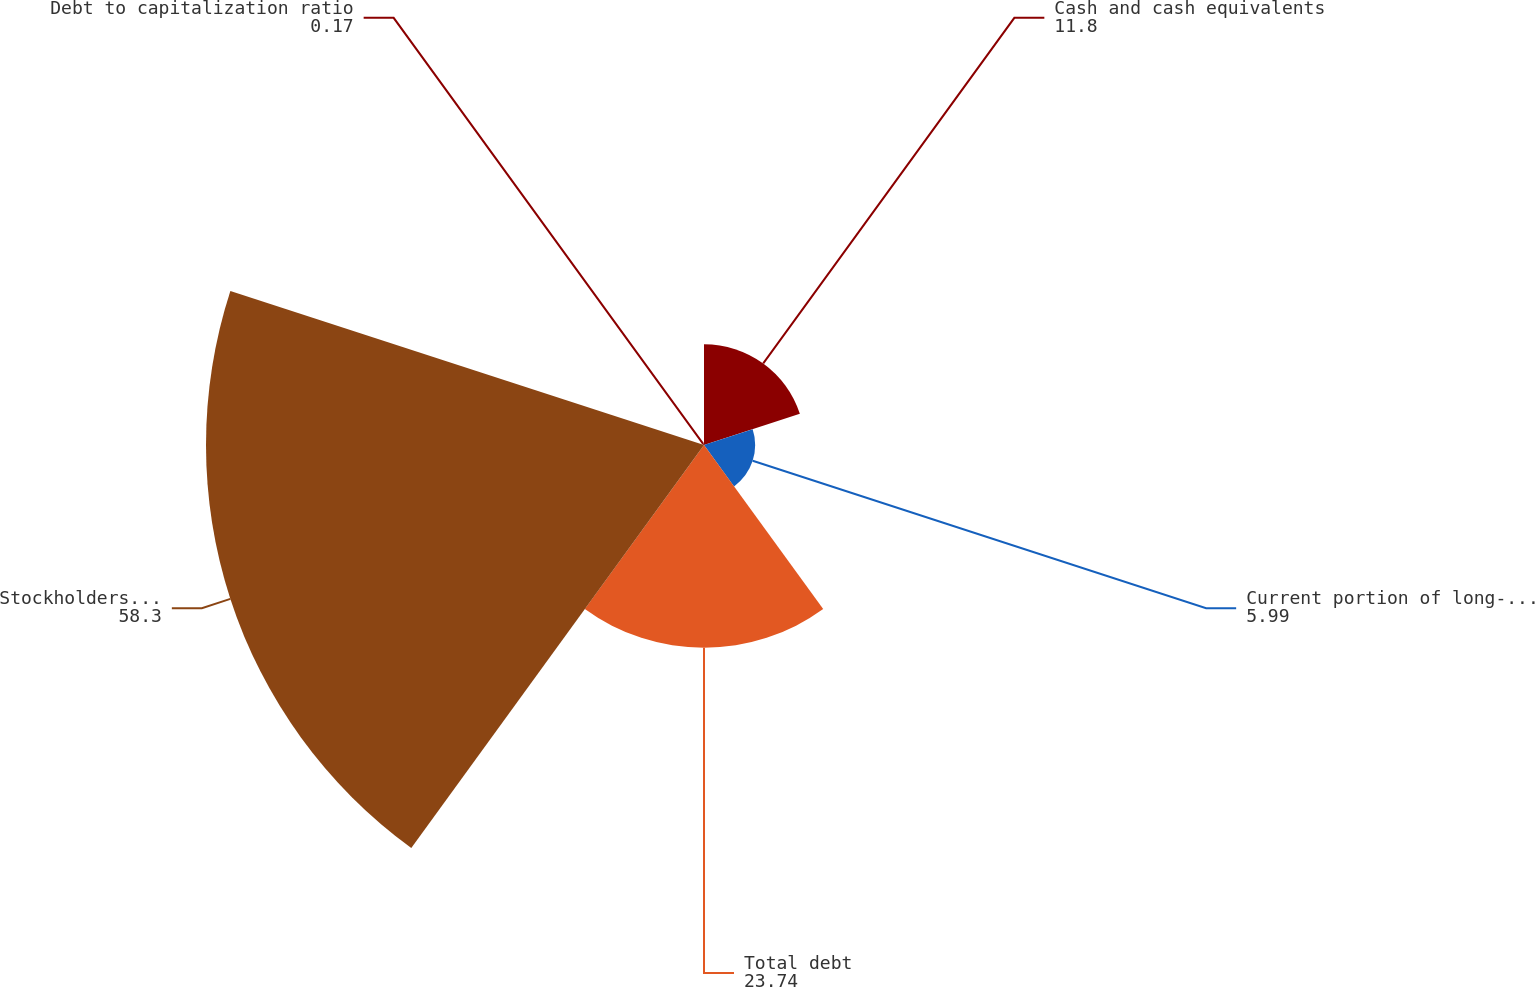Convert chart. <chart><loc_0><loc_0><loc_500><loc_500><pie_chart><fcel>Cash and cash equivalents<fcel>Current portion of long-term<fcel>Total debt<fcel>Stockholders' equity<fcel>Debt to capitalization ratio<nl><fcel>11.8%<fcel>5.99%<fcel>23.74%<fcel>58.3%<fcel>0.17%<nl></chart> 